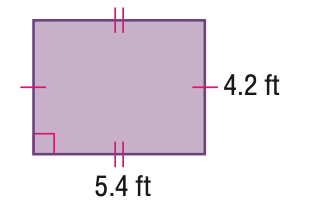Answer the mathemtical geometry problem and directly provide the correct option letter.
Question: Find the perimeter of the parallelogram. Round to the nearest tenth if necessary.
Choices: A: 16.8 B: 19.2 C: 21.6 D: 22.7 B 